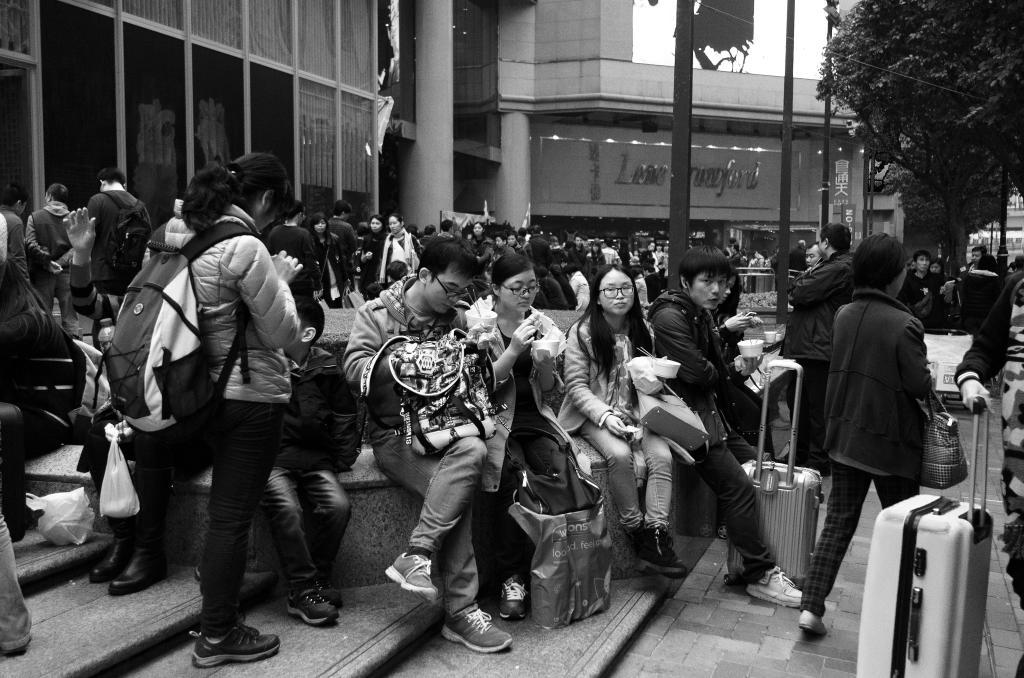What are the people in the image doing? The people in the image are sitting on the road. What can be seen in the background of the image? There is a building and trees in the background of the image. What is the color scheme of the image? The image is in black and white color. How many grapes are on the plate in the image? There are no grapes or plates present in the image. 